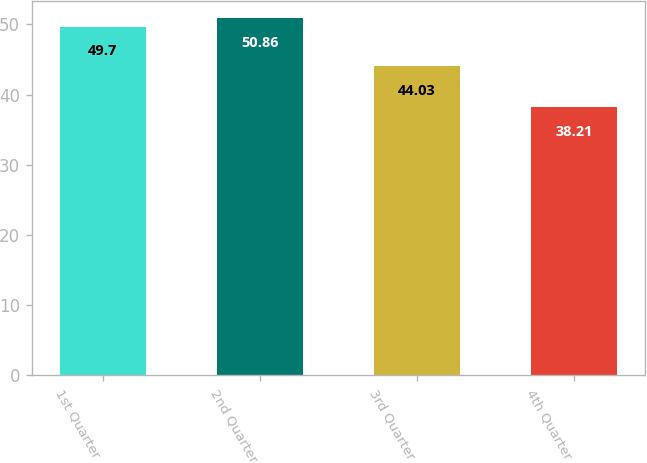Convert chart. <chart><loc_0><loc_0><loc_500><loc_500><bar_chart><fcel>1st Quarter<fcel>2nd Quarter<fcel>3rd Quarter<fcel>4th Quarter<nl><fcel>49.7<fcel>50.86<fcel>44.03<fcel>38.21<nl></chart> 